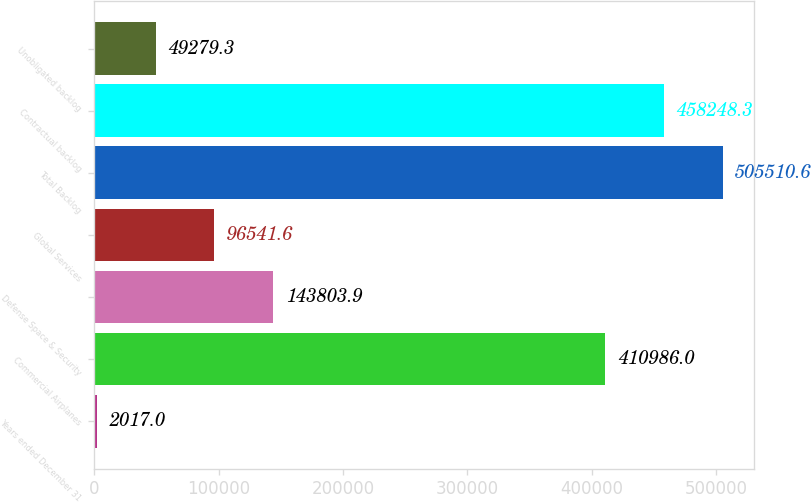<chart> <loc_0><loc_0><loc_500><loc_500><bar_chart><fcel>Years ended December 31<fcel>Commercial Airplanes<fcel>Defense Space & Security<fcel>Global Services<fcel>Total Backlog<fcel>Contractual backlog<fcel>Unobligated backlog<nl><fcel>2017<fcel>410986<fcel>143804<fcel>96541.6<fcel>505511<fcel>458248<fcel>49279.3<nl></chart> 